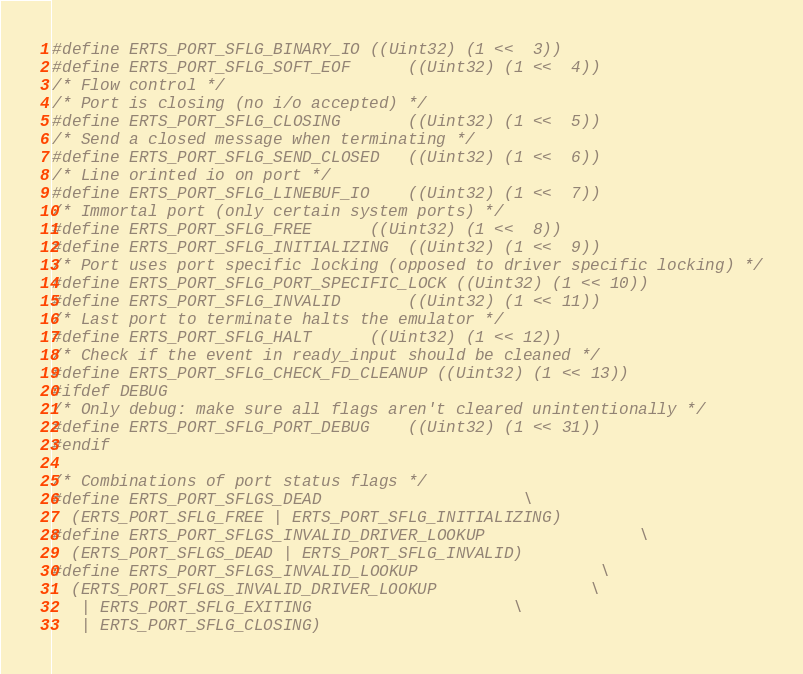<code> <loc_0><loc_0><loc_500><loc_500><_C_>#define ERTS_PORT_SFLG_BINARY_IO	((Uint32) (1 <<  3))
#define ERTS_PORT_SFLG_SOFT_EOF		((Uint32) (1 <<  4))
/* Flow control */
/* Port is closing (no i/o accepted) */
#define ERTS_PORT_SFLG_CLOSING		((Uint32) (1 <<  5))
/* Send a closed message when terminating */
#define ERTS_PORT_SFLG_SEND_CLOSED	((Uint32) (1 <<  6))
/* Line orinted io on port */  
#define ERTS_PORT_SFLG_LINEBUF_IO	((Uint32) (1 <<  7))
/* Immortal port (only certain system ports) */
#define ERTS_PORT_SFLG_FREE		((Uint32) (1 <<  8))
#define ERTS_PORT_SFLG_INITIALIZING	((Uint32) (1 <<  9))
/* Port uses port specific locking (opposed to driver specific locking) */
#define ERTS_PORT_SFLG_PORT_SPECIFIC_LOCK ((Uint32) (1 << 10))
#define ERTS_PORT_SFLG_INVALID		((Uint32) (1 << 11))
/* Last port to terminate halts the emulator */
#define ERTS_PORT_SFLG_HALT		((Uint32) (1 << 12))
/* Check if the event in ready_input should be cleaned */
#define ERTS_PORT_SFLG_CHECK_FD_CLEANUP ((Uint32) (1 << 13))
#ifdef DEBUG
/* Only debug: make sure all flags aren't cleared unintentionally */
#define ERTS_PORT_SFLG_PORT_DEBUG	((Uint32) (1 << 31))
#endif

/* Combinations of port status flags */ 
#define ERTS_PORT_SFLGS_DEAD						\
  (ERTS_PORT_SFLG_FREE | ERTS_PORT_SFLG_INITIALIZING)
#define ERTS_PORT_SFLGS_INVALID_DRIVER_LOOKUP				\
  (ERTS_PORT_SFLGS_DEAD | ERTS_PORT_SFLG_INVALID)
#define ERTS_PORT_SFLGS_INVALID_LOOKUP					\
  (ERTS_PORT_SFLGS_INVALID_DRIVER_LOOKUP				\
   | ERTS_PORT_SFLG_EXITING						\
   | ERTS_PORT_SFLG_CLOSING)</code> 